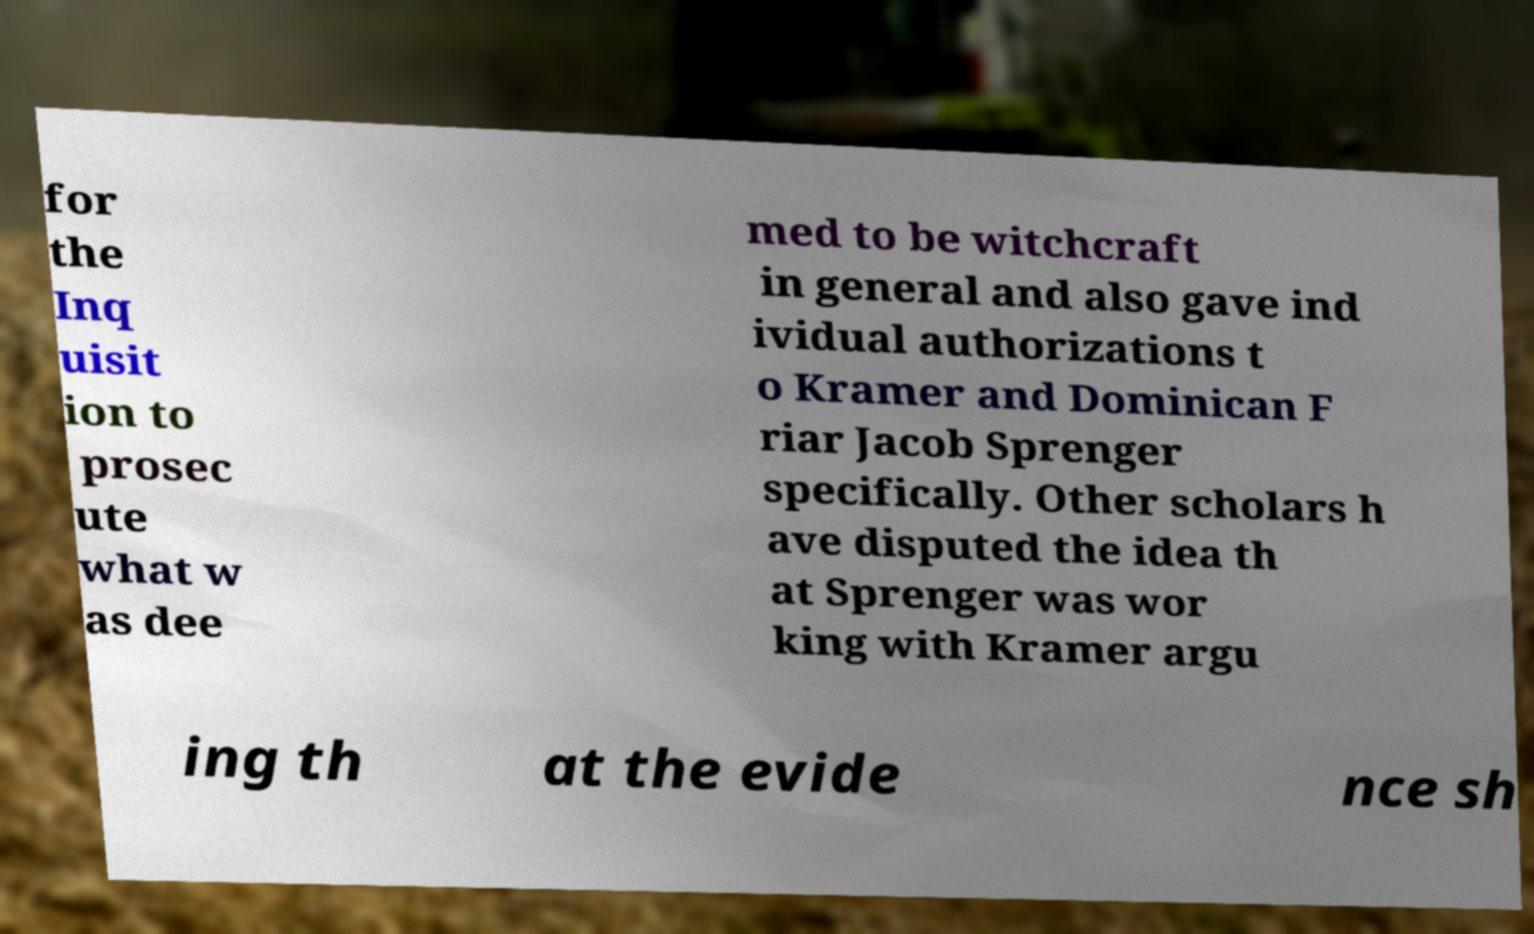Could you assist in decoding the text presented in this image and type it out clearly? for the Inq uisit ion to prosec ute what w as dee med to be witchcraft in general and also gave ind ividual authorizations t o Kramer and Dominican F riar Jacob Sprenger specifically. Other scholars h ave disputed the idea th at Sprenger was wor king with Kramer argu ing th at the evide nce sh 